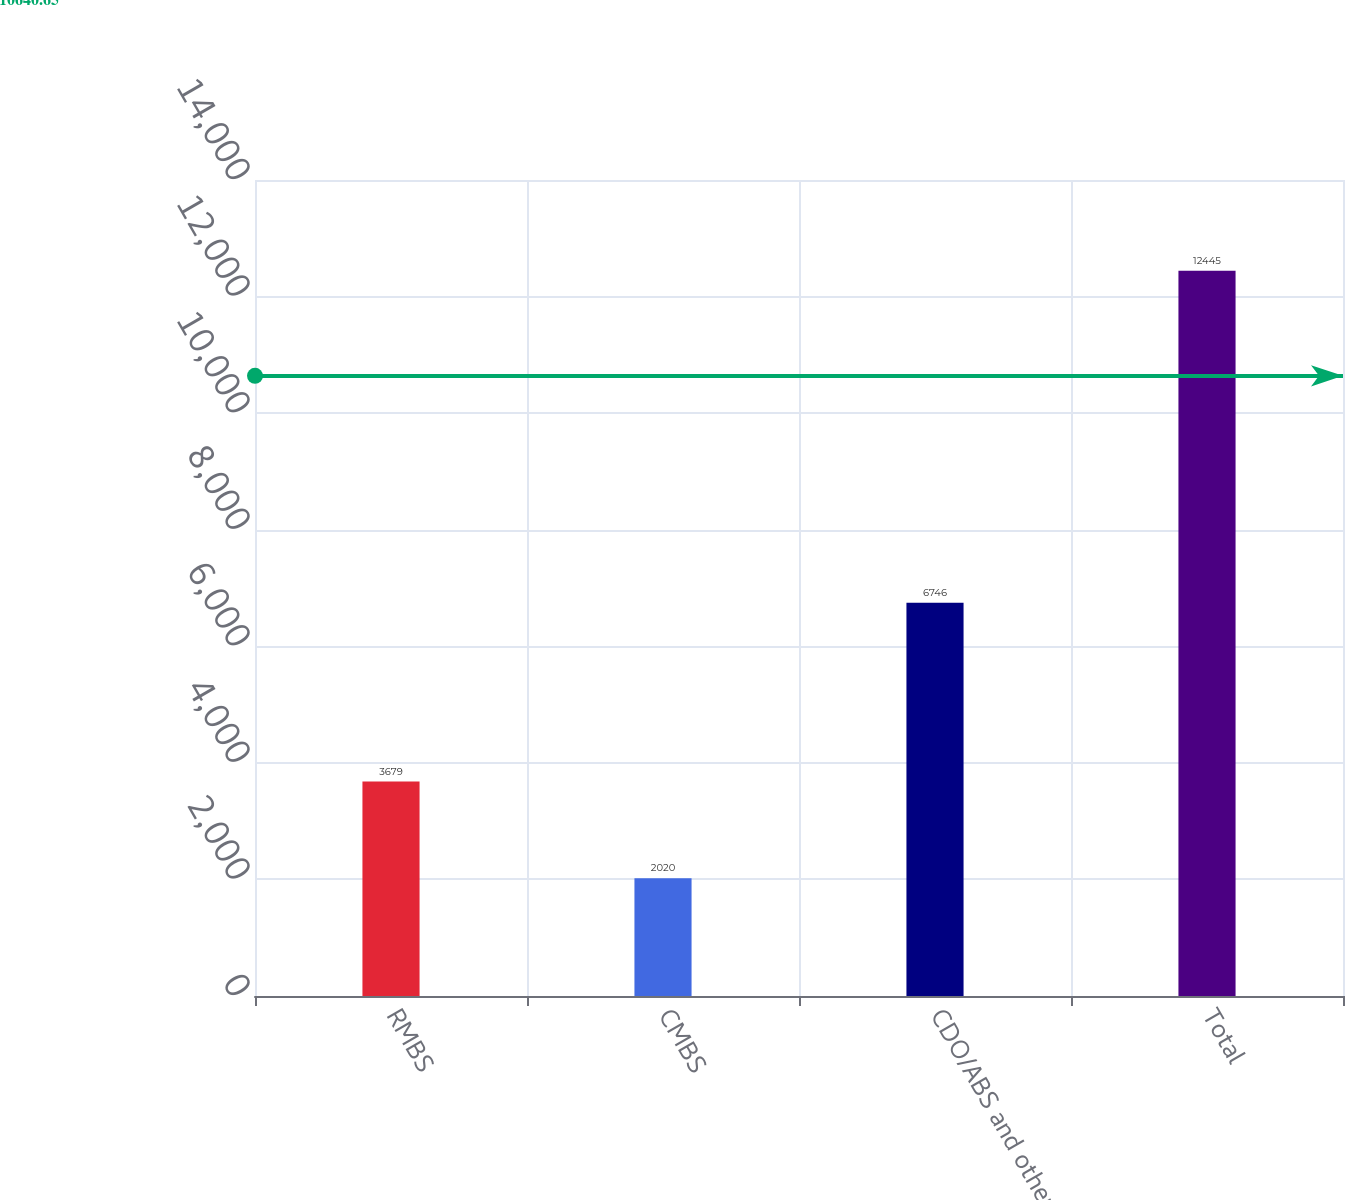Convert chart. <chart><loc_0><loc_0><loc_500><loc_500><bar_chart><fcel>RMBS<fcel>CMBS<fcel>CDO/ABS and other<fcel>Total<nl><fcel>3679<fcel>2020<fcel>6746<fcel>12445<nl></chart> 